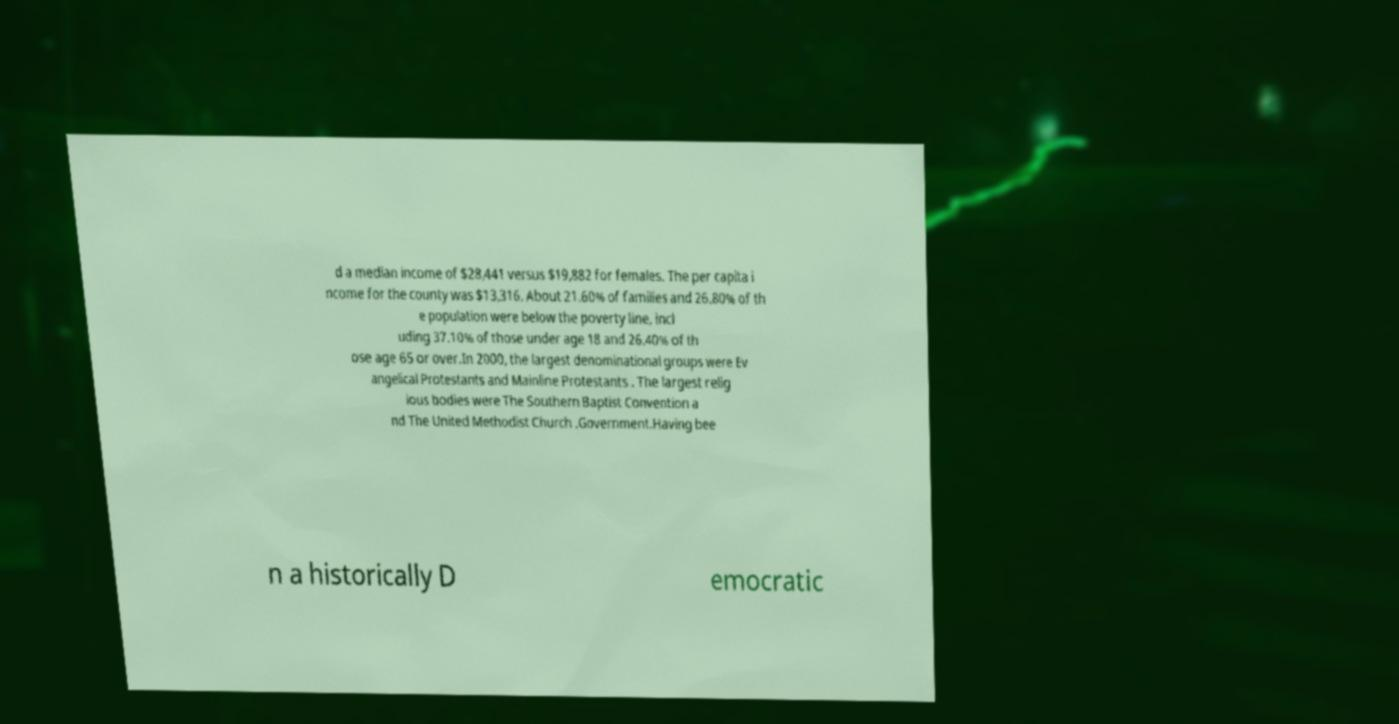I need the written content from this picture converted into text. Can you do that? d a median income of $28,441 versus $19,882 for females. The per capita i ncome for the county was $13,316. About 21.60% of families and 26.80% of th e population were below the poverty line, incl uding 37.10% of those under age 18 and 26.40% of th ose age 65 or over.In 2000, the largest denominational groups were Ev angelical Protestants and Mainline Protestants . The largest relig ious bodies were The Southern Baptist Convention a nd The United Methodist Church .Government.Having bee n a historically D emocratic 